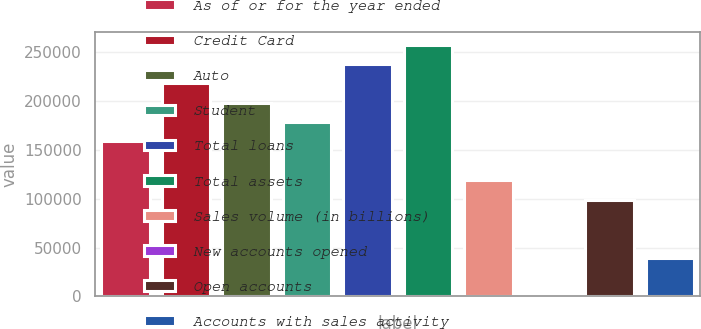Convert chart to OTSL. <chart><loc_0><loc_0><loc_500><loc_500><bar_chart><fcel>As of or for the year ended<fcel>Credit Card<fcel>Auto<fcel>Student<fcel>Total loans<fcel>Total assets<fcel>Sales volume (in billions)<fcel>New accounts opened<fcel>Open accounts<fcel>Accounts with sales activity<nl><fcel>158613<fcel>218091<fcel>198265<fcel>178439<fcel>237917<fcel>257742<fcel>118962<fcel>7.3<fcel>99136.1<fcel>39658.8<nl></chart> 